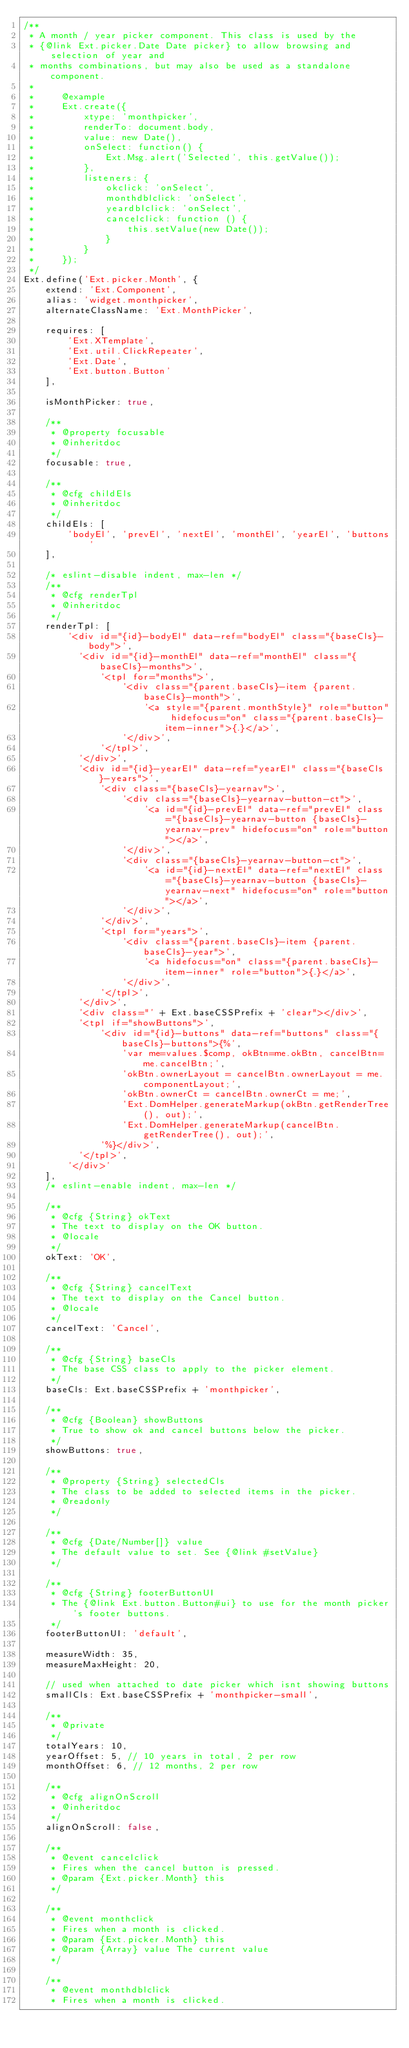<code> <loc_0><loc_0><loc_500><loc_500><_JavaScript_>/**
 * A month / year picker component. This class is used by the 
 * {@link Ext.picker.Date Date picker} to allow browsing and selection of year and 
 * months combinations, but may also be used as a standalone component.
 *
 *     @example
 *     Ext.create({
 *         xtype: 'monthpicker',
 *         renderTo: document.body,
 *         value: new Date(),
 *         onSelect: function() {
 *             Ext.Msg.alert('Selected', this.getValue());
 *         },
 *         listeners: {
 *             okclick: 'onSelect',
 *             monthdblclick: 'onSelect',
 *             yeardblclick: 'onSelect',
 *             cancelclick: function () {
 *                 this.setValue(new Date());
 *             }
 *         }
 *     });
 */
Ext.define('Ext.picker.Month', {
    extend: 'Ext.Component',
    alias: 'widget.monthpicker',
    alternateClassName: 'Ext.MonthPicker',

    requires: [
        'Ext.XTemplate',
        'Ext.util.ClickRepeater',
        'Ext.Date',
        'Ext.button.Button'
    ],

    isMonthPicker: true,

    /**
     * @property focusable
     * @inheritdoc
     */
    focusable: true,

    /**
     * @cfg childEls
     * @inheritdoc
     */
    childEls: [
        'bodyEl', 'prevEl', 'nextEl', 'monthEl', 'yearEl', 'buttons'
    ],

    /* eslint-disable indent, max-len */
    /**
     * @cfg renderTpl
     * @inheritdoc
     */
    renderTpl: [
        '<div id="{id}-bodyEl" data-ref="bodyEl" class="{baseCls}-body">',
          '<div id="{id}-monthEl" data-ref="monthEl" class="{baseCls}-months">',
              '<tpl for="months">',
                  '<div class="{parent.baseCls}-item {parent.baseCls}-month">',
                      '<a style="{parent.monthStyle}" role="button" hidefocus="on" class="{parent.baseCls}-item-inner">{.}</a>',
                  '</div>',
              '</tpl>',
          '</div>',
          '<div id="{id}-yearEl" data-ref="yearEl" class="{baseCls}-years">',
              '<div class="{baseCls}-yearnav">',
                  '<div class="{baseCls}-yearnav-button-ct">',
                      '<a id="{id}-prevEl" data-ref="prevEl" class="{baseCls}-yearnav-button {baseCls}-yearnav-prev" hidefocus="on" role="button"></a>',
                  '</div>',
                  '<div class="{baseCls}-yearnav-button-ct">',
                      '<a id="{id}-nextEl" data-ref="nextEl" class="{baseCls}-yearnav-button {baseCls}-yearnav-next" hidefocus="on" role="button"></a>',
                  '</div>',
              '</div>',
              '<tpl for="years">',
                  '<div class="{parent.baseCls}-item {parent.baseCls}-year">',
                      '<a hidefocus="on" class="{parent.baseCls}-item-inner" role="button">{.}</a>',
                  '</div>',
              '</tpl>',
          '</div>',
          '<div class="' + Ext.baseCSSPrefix + 'clear"></div>',
          '<tpl if="showButtons">',
              '<div id="{id}-buttons" data-ref="buttons" class="{baseCls}-buttons">{%',
                  'var me=values.$comp, okBtn=me.okBtn, cancelBtn=me.cancelBtn;',
                  'okBtn.ownerLayout = cancelBtn.ownerLayout = me.componentLayout;',
                  'okBtn.ownerCt = cancelBtn.ownerCt = me;',
                  'Ext.DomHelper.generateMarkup(okBtn.getRenderTree(), out);',
                  'Ext.DomHelper.generateMarkup(cancelBtn.getRenderTree(), out);',
              '%}</div>',
          '</tpl>',
        '</div>'
    ],
    /* eslint-enable indent, max-len */

    /**
     * @cfg {String} okText
     * The text to display on the OK button.
     * @locale
     */
    okText: 'OK',

    /**
     * @cfg {String} cancelText
     * The text to display on the Cancel button.
     * @locale
     */
    cancelText: 'Cancel',

    /**
     * @cfg {String} baseCls
     * The base CSS class to apply to the picker element.
     */
    baseCls: Ext.baseCSSPrefix + 'monthpicker',

    /**
     * @cfg {Boolean} showButtons
     * True to show ok and cancel buttons below the picker.
     */
    showButtons: true,

    /**
     * @property {String} selectedCls
     * The class to be added to selected items in the picker.
     * @readonly
     */

    /**
     * @cfg {Date/Number[]} value
     * The default value to set. See {@link #setValue}
     */

    /**
     * @cfg {String} footerButtonUI
     * The {@link Ext.button.Button#ui} to use for the month picker's footer buttons.
     */
    footerButtonUI: 'default',

    measureWidth: 35,
    measureMaxHeight: 20,

    // used when attached to date picker which isnt showing buttons
    smallCls: Ext.baseCSSPrefix + 'monthpicker-small',

    /**
     * @private
     */
    totalYears: 10,
    yearOffset: 5, // 10 years in total, 2 per row
    monthOffset: 6, // 12 months, 2 per row

    /**
     * @cfg alignOnScroll
     * @inheritdoc
     */
    alignOnScroll: false,

    /**
     * @event cancelclick
     * Fires when the cancel button is pressed.
     * @param {Ext.picker.Month} this
     */

    /**
     * @event monthclick
     * Fires when a month is clicked.
     * @param {Ext.picker.Month} this
     * @param {Array} value The current value
     */

    /**
     * @event monthdblclick
     * Fires when a month is clicked.</code> 